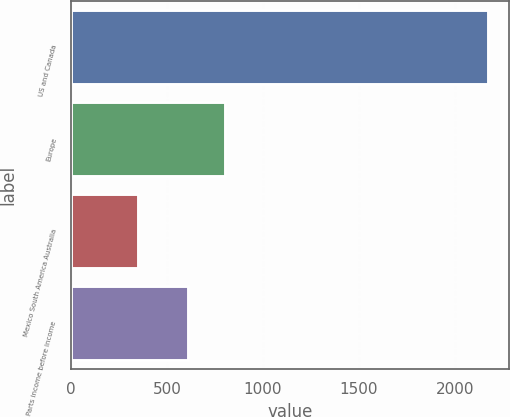<chart> <loc_0><loc_0><loc_500><loc_500><bar_chart><fcel>US and Canada<fcel>Europe<fcel>Mexico South America Australia<fcel>Parts income before income<nl><fcel>2175<fcel>801<fcel>351<fcel>610<nl></chart> 